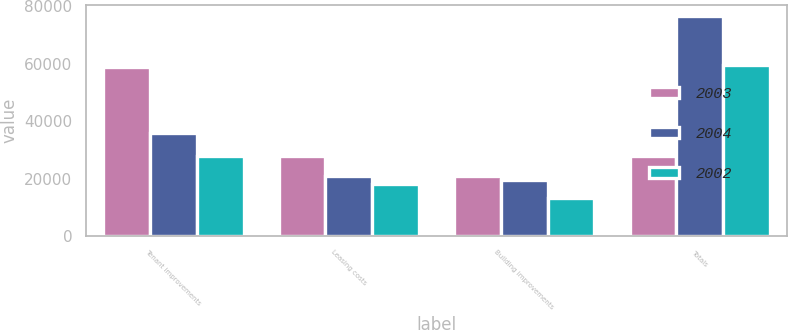<chart> <loc_0><loc_0><loc_500><loc_500><stacked_bar_chart><ecel><fcel>Tenant improvements<fcel>Leasing costs<fcel>Building improvements<fcel>Totals<nl><fcel>2003<fcel>58847<fcel>27777<fcel>21029<fcel>27777<nl><fcel>2004<fcel>35972<fcel>20932<fcel>19544<fcel>76448<nl><fcel>2002<fcel>28011<fcel>17975<fcel>13373<fcel>59359<nl></chart> 